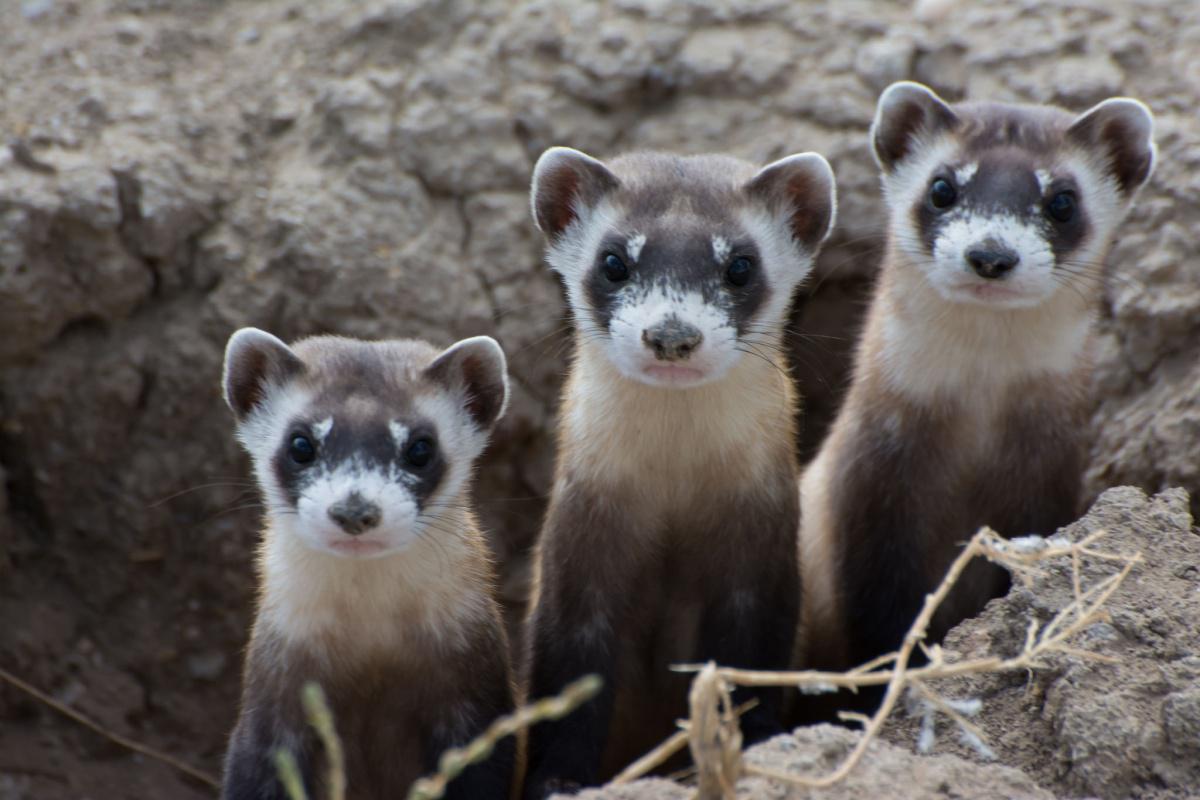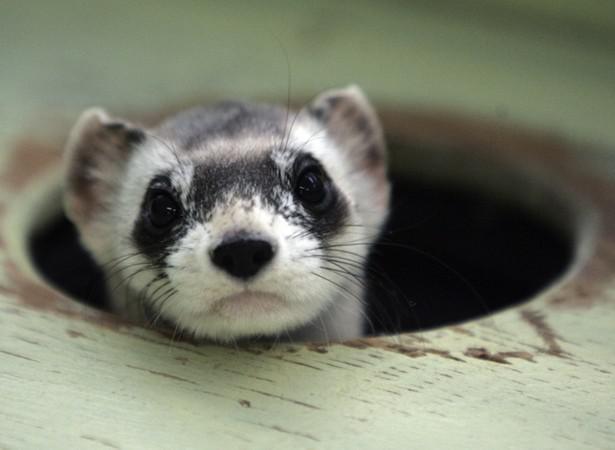The first image is the image on the left, the second image is the image on the right. Evaluate the accuracy of this statement regarding the images: "The right image contains a ferret sticking their head out of a dirt hole.". Is it true? Answer yes or no. No. 